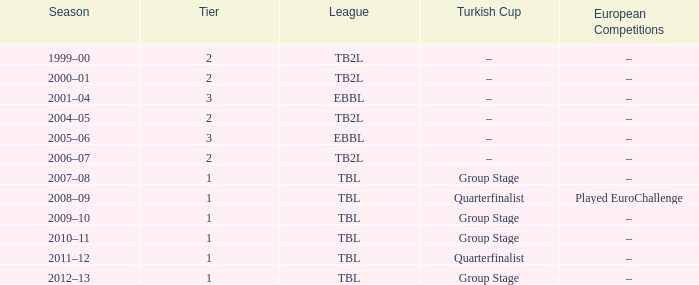Tier of 2, and a Season of 2004–05 is what European competitions? –. 